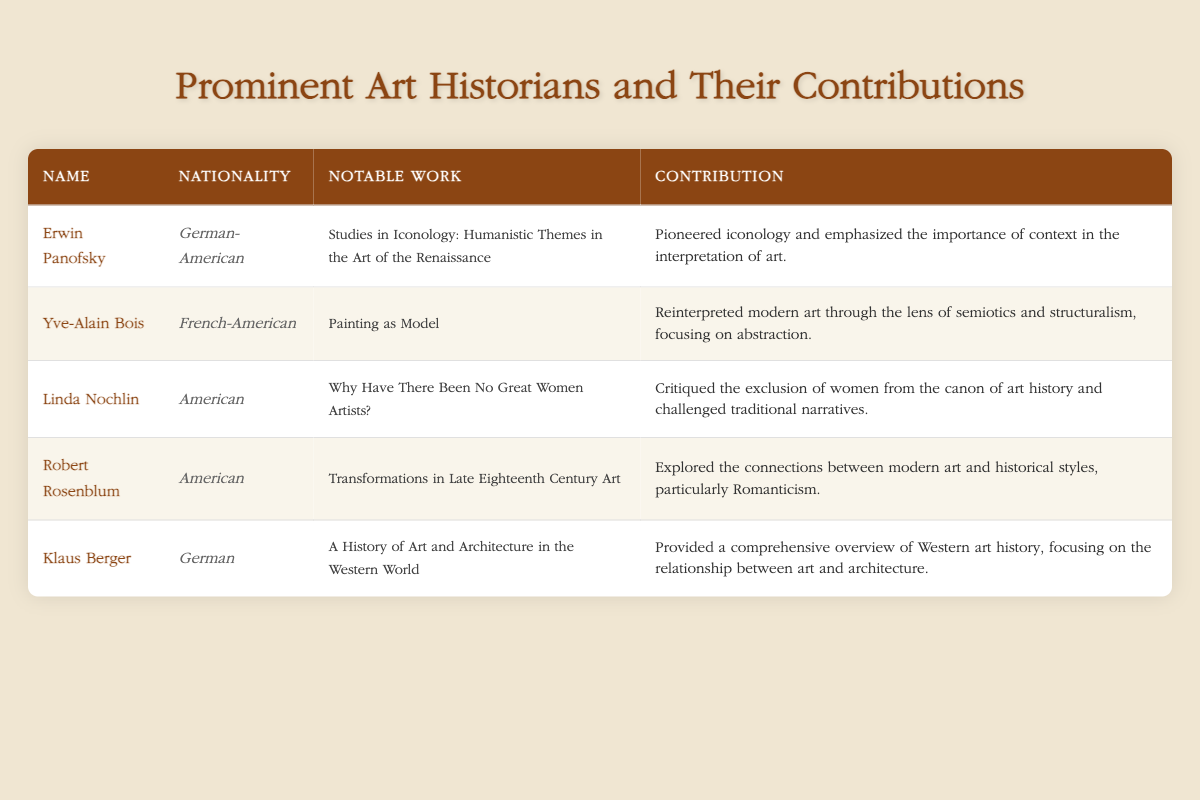What is the notable work of Linda Nochlin? According to the table, the notable work of Linda Nochlin is "Why Have There Been No Great Women Artists?"
Answer: Why Have There Been No Great Women Artists? Which art historian has a German-American nationality? The table lists Erwin Panofsky as the art historian with German-American nationality.
Answer: Erwin Panofsky Did Klaus Berger contribute to the interpretation of modern art? The table indicates that Klaus Berger focused on the relationship between art and architecture, but he did not specifically mention modern art interpretation. Thus, this statement is false.
Answer: No What is the contribution of Yve-Alain Bois according to the table? Yve-Alain Bois's contribution mentioned in the table is that he reinterpreted modern art through the lens of semiotics and structuralism, focusing on abstraction.
Answer: Reinterpreted modern art through semiotics and structuralism How many American art historians are listed in the table? In the table, there are two American art historians: Linda Nochlin and Robert Rosenblum. Therefore, the count is 2.
Answer: 2 